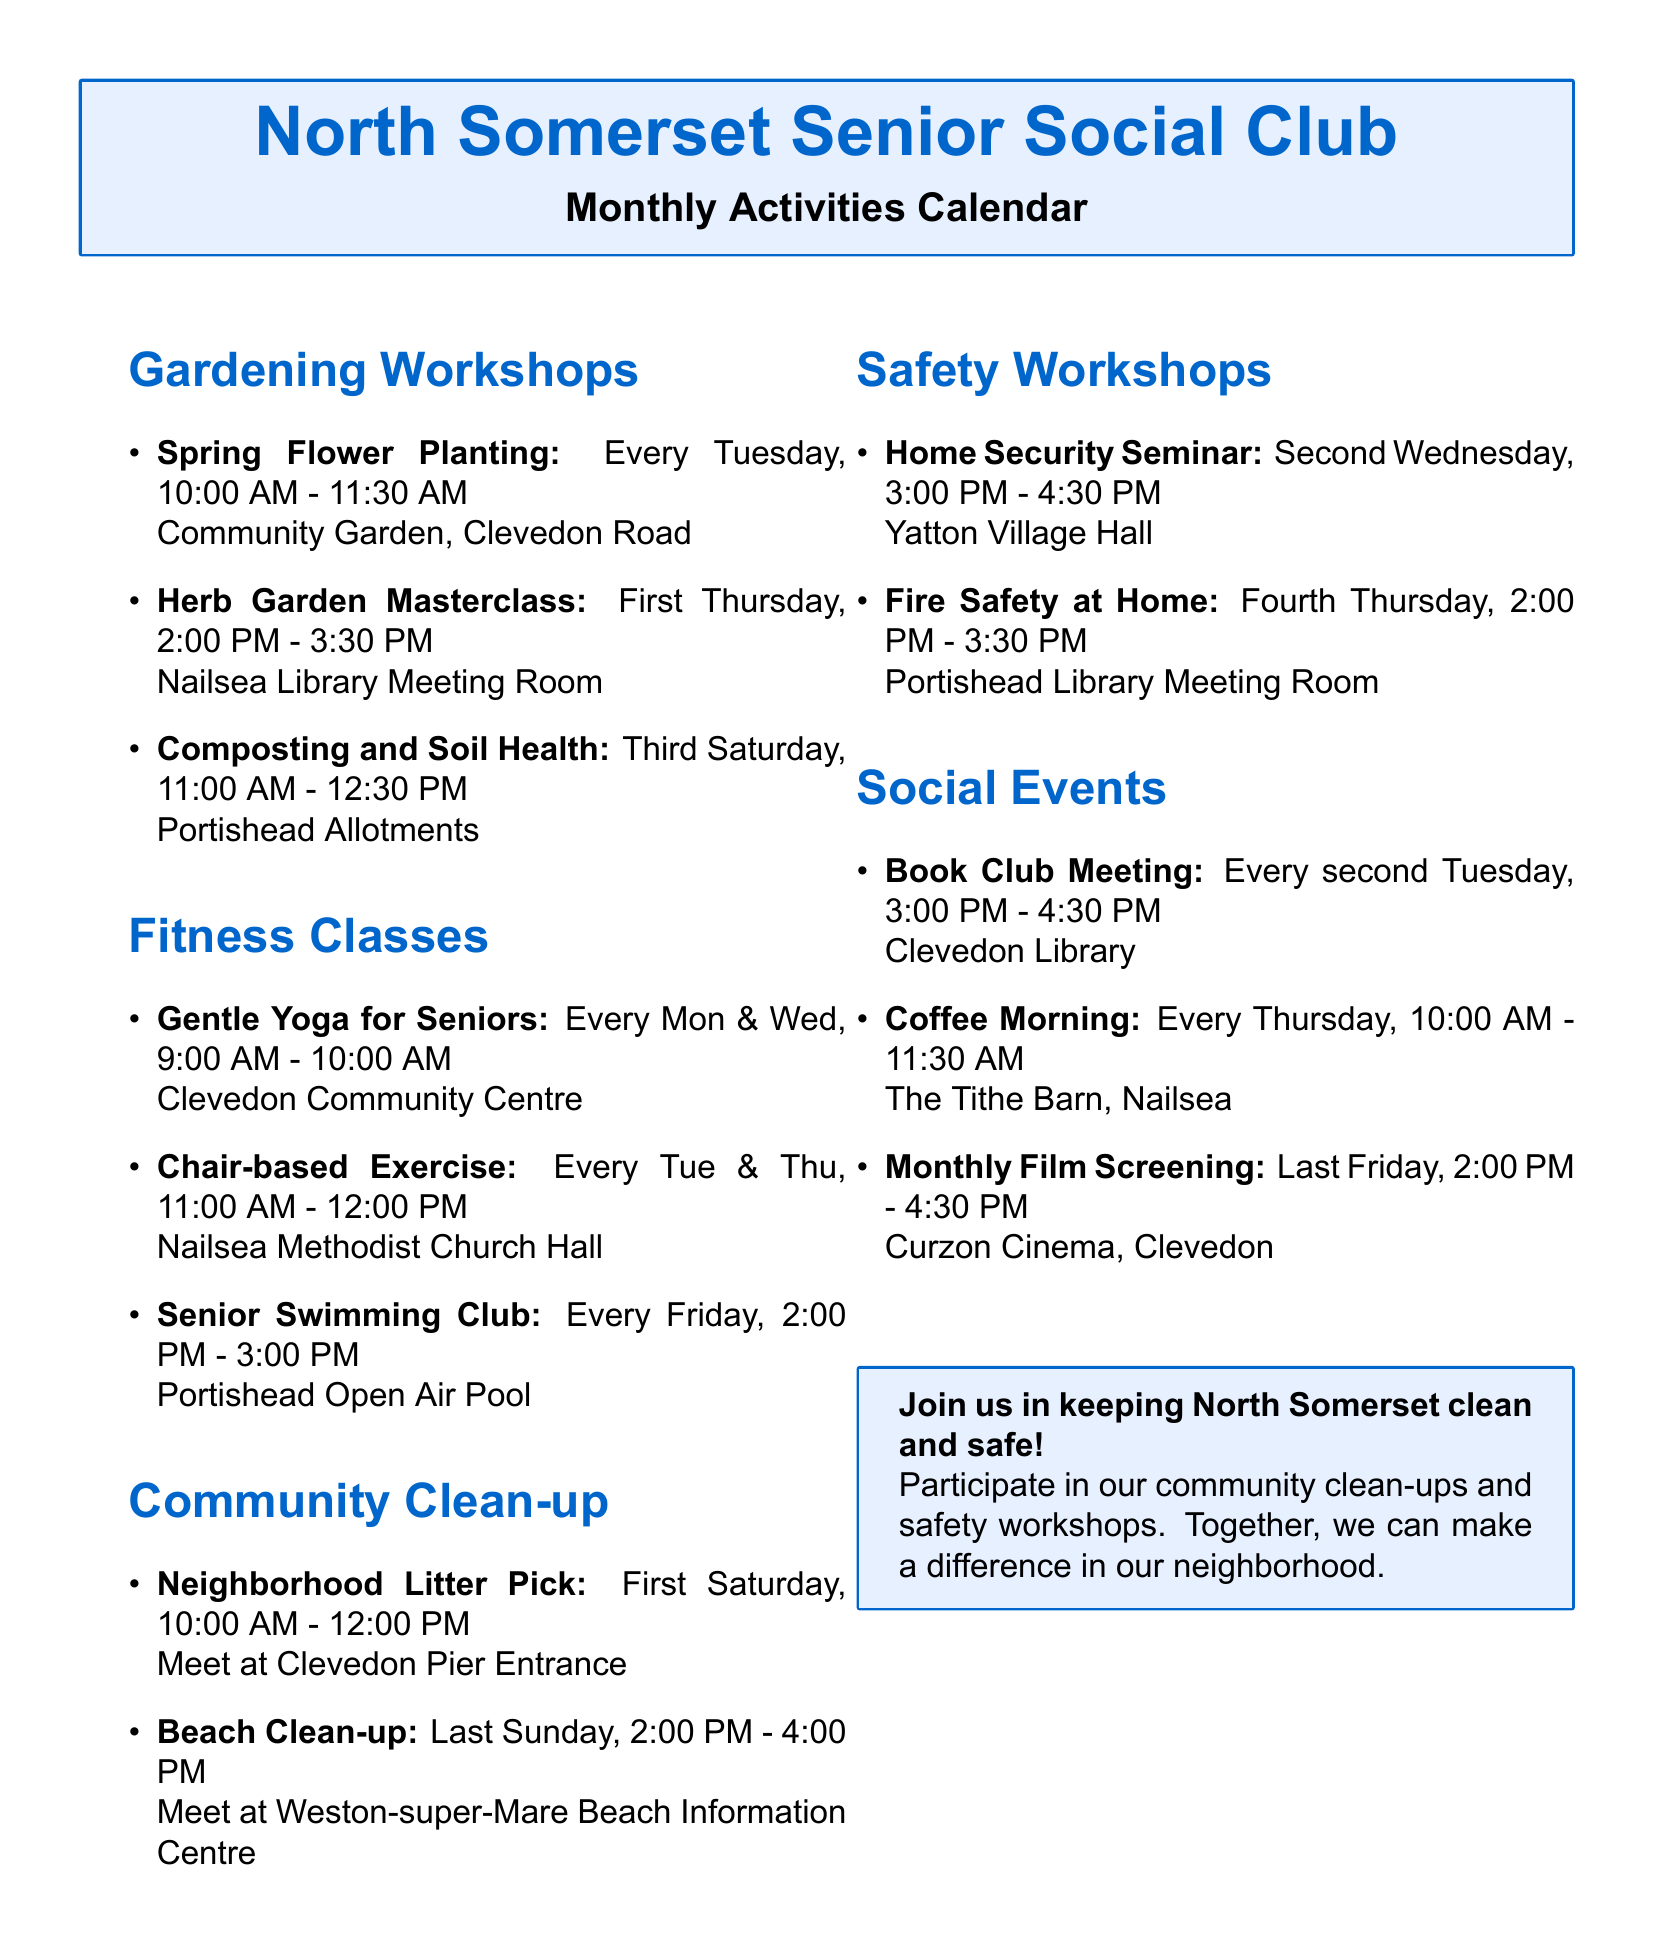what day is the Senior Swimming Club held? The Senior Swimming Club is scheduled for every Friday.
Answer: Every Friday who is the instructor for the Herb Garden Masterclass? The Herb Garden Masterclass is taught by John Davies.
Answer: John Davies when does the Neighborhood Litter Pick take place? The Neighborhood Litter Pick is on the first Saturday of the month.
Answer: First Saturday of the month which fitness class is held on Mondays? The fitness class held on Mondays is Gentle Yoga for Seniors.
Answer: Gentle Yoga for Seniors where is the Coffee Morning hosted? The Coffee Morning takes place at The Tithe Barn, Nailsea.
Answer: The Tithe Barn, Nailsea how often do the Gardening Workshops occur? The Gardening Workshops occur weekly and monthly, with specific activities scheduled regularly.
Answer: Weekly and monthly who coordinates the Beach Clean-up activity? The Beach Clean-up is coordinated by Angela Smith.
Answer: Angela Smith what is the time for the Fire Safety at Home workshop? The Fire Safety at Home workshop is scheduled from 2:00 PM to 3:30 PM.
Answer: 2:00 PM - 3:30 PM how long does the Book Club Meeting last? The Book Club Meeting lasts for one and a half hours.
Answer: One and a half hours 